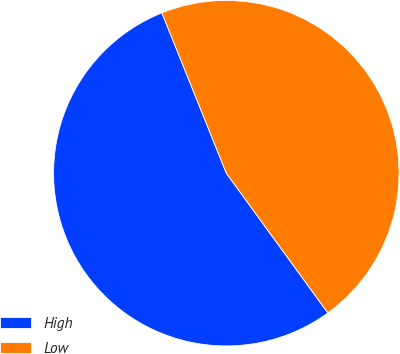Convert chart. <chart><loc_0><loc_0><loc_500><loc_500><pie_chart><fcel>High<fcel>Low<nl><fcel>53.92%<fcel>46.08%<nl></chart> 